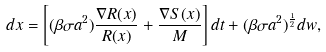Convert formula to latex. <formula><loc_0><loc_0><loc_500><loc_500>d x = \left [ ( \beta \sigma a ^ { 2 } ) \frac { \nabla R ( x ) } { R ( x ) } + \frac { \nabla S ( x ) } { M } \right ] d t + ( \beta \sigma a ^ { 2 } ) ^ { \frac { 1 } { 2 } } d w ,</formula> 